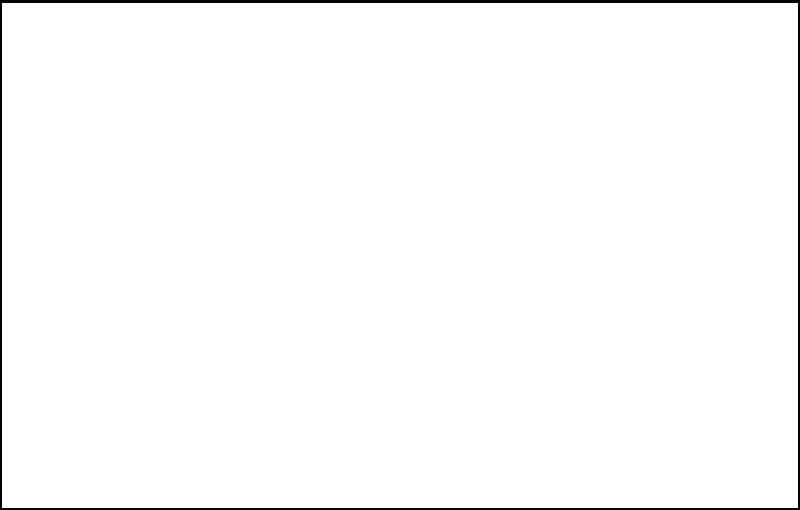A soccer field is rectangular in shape, measuring 110 meters in length and 70 meters in width. If a circle is inscribed within this rectangle, what is the radius of the circle in meters? Let's approach this step-by-step:

1) In a rectangle with an inscribed circle, the diameter of the circle is equal to the width of the rectangle.

2) The width of the rectangle (soccer field) is 70 meters. So, the diameter of the circle is also 70 meters.

3) The radius is half of the diameter. We can express this mathematically as:

   $$r = \frac{d}{2}$$

   where $r$ is the radius and $d$ is the diameter.

4) Substituting the known value:

   $$r = \frac{70}{2} = 35$$

5) Therefore, the radius of the inscribed circle is 35 meters.

Note: We didn't need to use the length of the rectangle (110 meters) for this calculation. The width alone determines the circle's size in this case.
Answer: 35 meters 